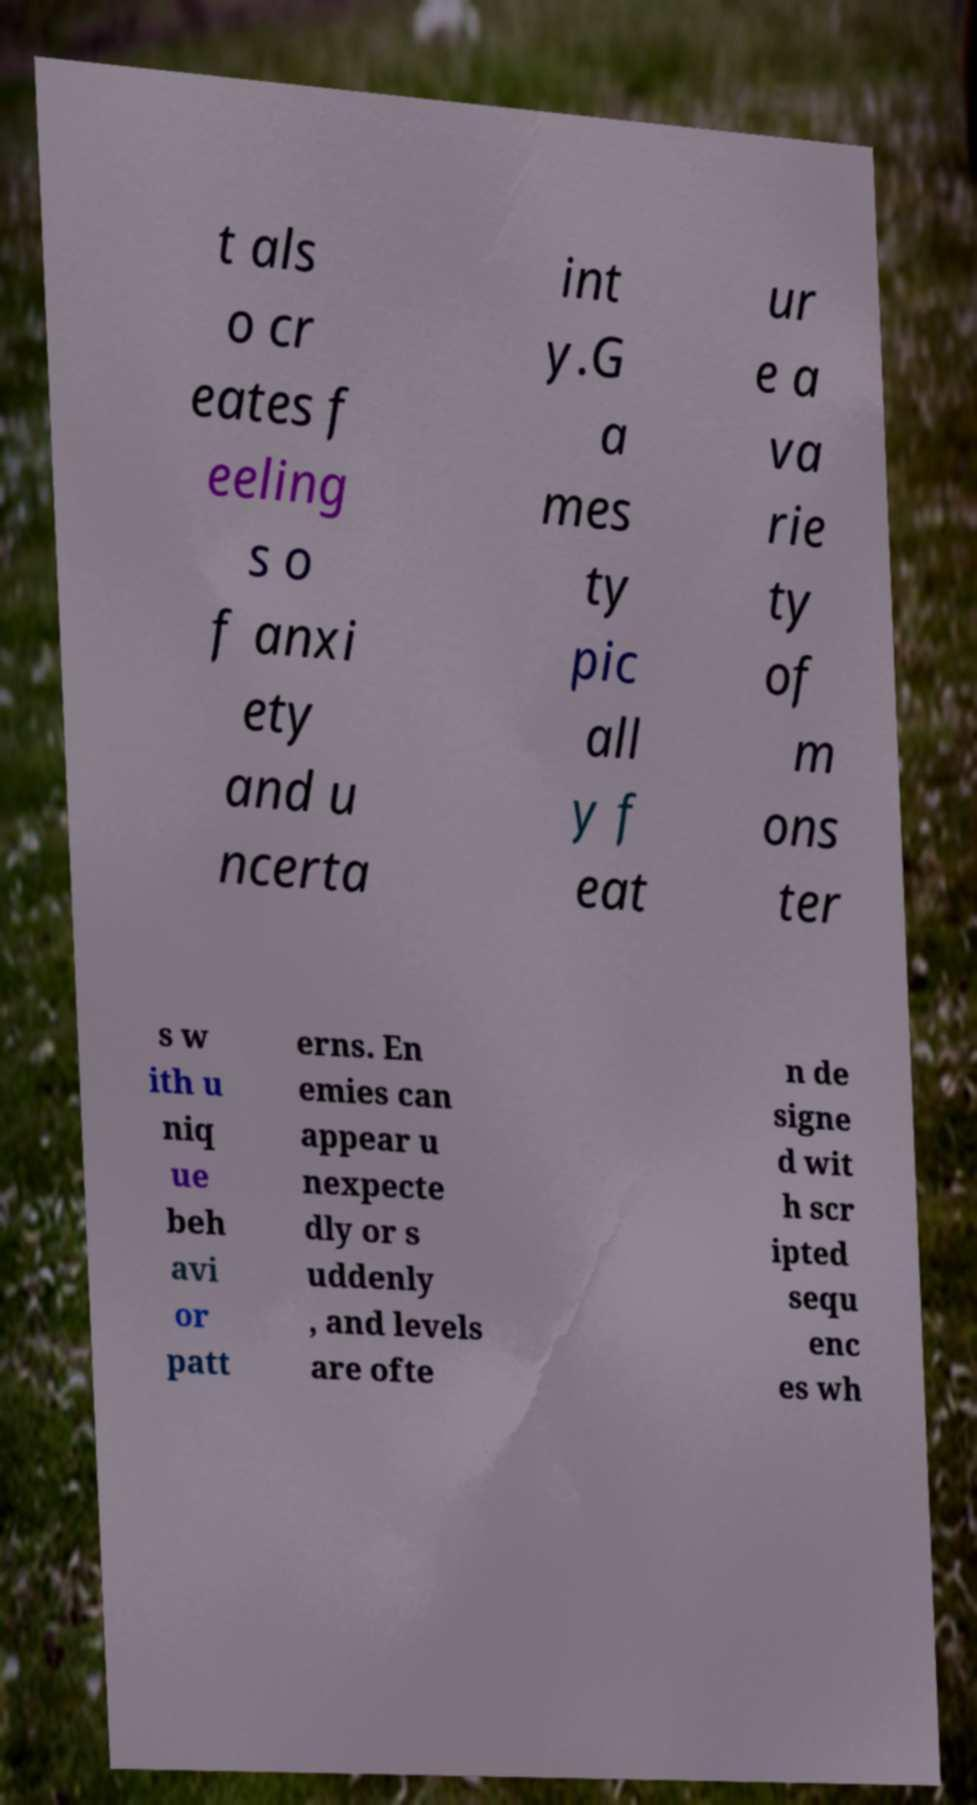Please read and relay the text visible in this image. What does it say? t als o cr eates f eeling s o f anxi ety and u ncerta int y.G a mes ty pic all y f eat ur e a va rie ty of m ons ter s w ith u niq ue beh avi or patt erns. En emies can appear u nexpecte dly or s uddenly , and levels are ofte n de signe d wit h scr ipted sequ enc es wh 